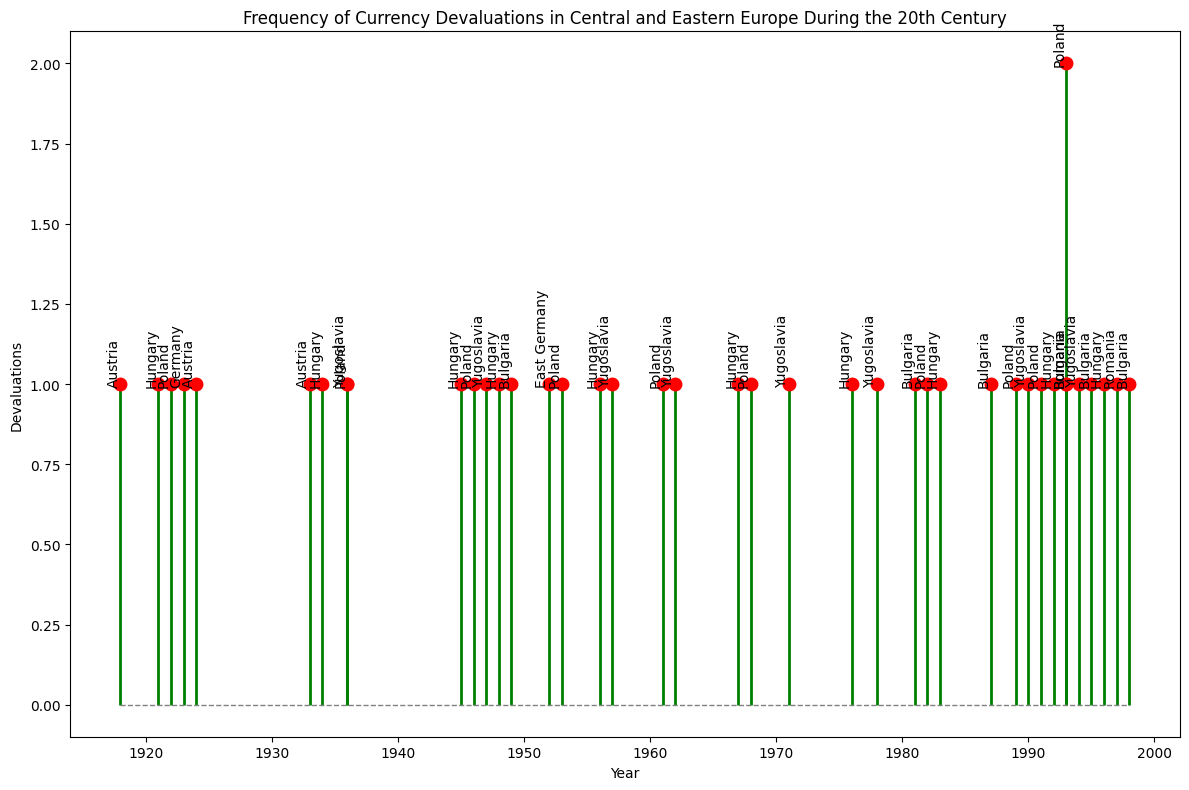In which year did Poland experience its highest number of currency devaluations? To determine this, we look at the plot for the year with the highest devaluation count for Poland. Notably, in 1993, it has the highest frequency of devaluations marked with a stem reaching up to 2.
Answer: 1993 Which country had devaluations in the most consistent time intervals during the 20th century? By examining the country labels on the stem plot over time, Hungary appears to have devaluations roughly every few years spread across multiple decades, showing consistency without long periods of inactivity. The frequencies in years such as 1921, 1934, 1945, and so on, illustrate this regularity.
Answer: Hungary How many total currency devaluations did Bulgaria experience? By counting the number of devaluations marked on the plot for Bulgaria, we identify them in the years 1949, 1981, 1987, 1993, 1995, and 1998. Thus, Bulgaria experienced 6 devaluations.
Answer: 6 Between the 1920s and the 1940s, which country experienced the most devaluations? Count the number of devaluations for each country during the period 1920-1940. Poland experienced 2 devaluations (1922, 1936), Hungary experienced 2 (1921, 1934), and Yugoslavia experienced 1 (1936). Austria had 3 (1918 counted as part of the early 1920s, 1924, and 1933), which is the most.
Answer: Austria What was the average interval (in years) between consecutive devaluations for Yugoslavia from the first to last recorded devaluation? List and calculate the intervals between the Yugoslavian devaluation years: 1936, 1947, 1957, 1962, 1971, 1978, 1990, 1994. The intervals are 11, 10, 5, 9, 7, 12, and 4 years. By summing, we get 58 years over 7 intervals. Dividing gives an average of 58/7 = 8.29 years approximately.
Answer: 8.29 years Which decade saw the highest frequency of overall currency devaluations in Central and Eastern Europe? By analyzing the concentration of stems in each decade, the 1990s stand out with events in multiple years and appearing taller due to multiple devaluations. Specifically, 1990, 1991, 1992, 1993, 1994, 1995, 1996, 1997, and 1998 show high activity, contributing to a significant count.
Answer: 1990s 